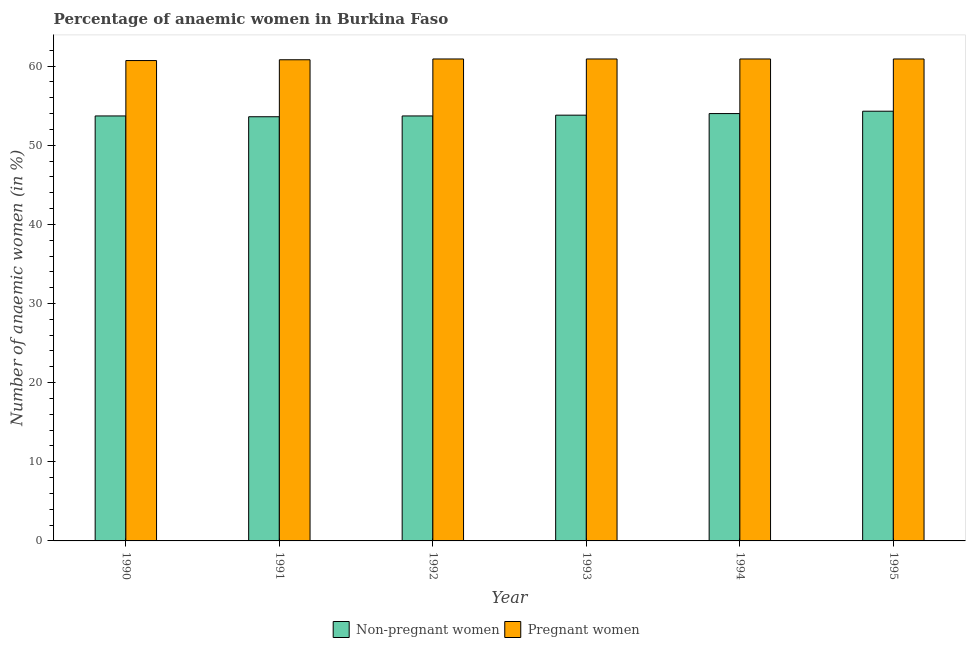How many groups of bars are there?
Ensure brevity in your answer.  6. How many bars are there on the 4th tick from the left?
Offer a terse response. 2. How many bars are there on the 2nd tick from the right?
Offer a terse response. 2. What is the label of the 1st group of bars from the left?
Provide a succinct answer. 1990. In how many cases, is the number of bars for a given year not equal to the number of legend labels?
Offer a terse response. 0. What is the percentage of non-pregnant anaemic women in 1990?
Provide a succinct answer. 53.7. Across all years, what is the maximum percentage of pregnant anaemic women?
Your response must be concise. 60.9. Across all years, what is the minimum percentage of non-pregnant anaemic women?
Offer a terse response. 53.6. In which year was the percentage of pregnant anaemic women minimum?
Provide a succinct answer. 1990. What is the total percentage of non-pregnant anaemic women in the graph?
Provide a succinct answer. 323.1. What is the difference between the percentage of pregnant anaemic women in 1992 and that in 1993?
Offer a very short reply. 0. What is the difference between the percentage of non-pregnant anaemic women in 1992 and the percentage of pregnant anaemic women in 1993?
Your answer should be compact. -0.1. What is the average percentage of non-pregnant anaemic women per year?
Provide a short and direct response. 53.85. In the year 1990, what is the difference between the percentage of non-pregnant anaemic women and percentage of pregnant anaemic women?
Ensure brevity in your answer.  0. In how many years, is the percentage of non-pregnant anaemic women greater than 24 %?
Give a very brief answer. 6. What is the ratio of the percentage of non-pregnant anaemic women in 1990 to that in 1991?
Provide a short and direct response. 1. What is the difference between the highest and the second highest percentage of pregnant anaemic women?
Your answer should be compact. 0. What is the difference between the highest and the lowest percentage of pregnant anaemic women?
Your answer should be compact. 0.2. In how many years, is the percentage of non-pregnant anaemic women greater than the average percentage of non-pregnant anaemic women taken over all years?
Make the answer very short. 2. Is the sum of the percentage of non-pregnant anaemic women in 1992 and 1994 greater than the maximum percentage of pregnant anaemic women across all years?
Ensure brevity in your answer.  Yes. What does the 1st bar from the left in 1994 represents?
Give a very brief answer. Non-pregnant women. What does the 1st bar from the right in 1990 represents?
Your response must be concise. Pregnant women. What is the difference between two consecutive major ticks on the Y-axis?
Make the answer very short. 10. Are the values on the major ticks of Y-axis written in scientific E-notation?
Give a very brief answer. No. Does the graph contain grids?
Make the answer very short. No. Where does the legend appear in the graph?
Ensure brevity in your answer.  Bottom center. How are the legend labels stacked?
Provide a short and direct response. Horizontal. What is the title of the graph?
Keep it short and to the point. Percentage of anaemic women in Burkina Faso. What is the label or title of the X-axis?
Your response must be concise. Year. What is the label or title of the Y-axis?
Offer a very short reply. Number of anaemic women (in %). What is the Number of anaemic women (in %) in Non-pregnant women in 1990?
Your answer should be very brief. 53.7. What is the Number of anaemic women (in %) of Pregnant women in 1990?
Ensure brevity in your answer.  60.7. What is the Number of anaemic women (in %) in Non-pregnant women in 1991?
Your answer should be compact. 53.6. What is the Number of anaemic women (in %) in Pregnant women in 1991?
Your answer should be very brief. 60.8. What is the Number of anaemic women (in %) in Non-pregnant women in 1992?
Provide a short and direct response. 53.7. What is the Number of anaemic women (in %) in Pregnant women in 1992?
Keep it short and to the point. 60.9. What is the Number of anaemic women (in %) of Non-pregnant women in 1993?
Your response must be concise. 53.8. What is the Number of anaemic women (in %) in Pregnant women in 1993?
Your answer should be very brief. 60.9. What is the Number of anaemic women (in %) of Pregnant women in 1994?
Your answer should be very brief. 60.9. What is the Number of anaemic women (in %) of Non-pregnant women in 1995?
Your response must be concise. 54.3. What is the Number of anaemic women (in %) in Pregnant women in 1995?
Provide a short and direct response. 60.9. Across all years, what is the maximum Number of anaemic women (in %) of Non-pregnant women?
Your answer should be compact. 54.3. Across all years, what is the maximum Number of anaemic women (in %) in Pregnant women?
Your answer should be compact. 60.9. Across all years, what is the minimum Number of anaemic women (in %) of Non-pregnant women?
Provide a succinct answer. 53.6. Across all years, what is the minimum Number of anaemic women (in %) in Pregnant women?
Your answer should be very brief. 60.7. What is the total Number of anaemic women (in %) of Non-pregnant women in the graph?
Provide a short and direct response. 323.1. What is the total Number of anaemic women (in %) in Pregnant women in the graph?
Your answer should be compact. 365.1. What is the difference between the Number of anaemic women (in %) of Pregnant women in 1990 and that in 1991?
Provide a succinct answer. -0.1. What is the difference between the Number of anaemic women (in %) of Pregnant women in 1990 and that in 1992?
Offer a very short reply. -0.2. What is the difference between the Number of anaemic women (in %) of Non-pregnant women in 1990 and that in 1993?
Ensure brevity in your answer.  -0.1. What is the difference between the Number of anaemic women (in %) in Pregnant women in 1990 and that in 1993?
Keep it short and to the point. -0.2. What is the difference between the Number of anaemic women (in %) in Pregnant women in 1991 and that in 1992?
Provide a succinct answer. -0.1. What is the difference between the Number of anaemic women (in %) of Non-pregnant women in 1991 and that in 1993?
Your response must be concise. -0.2. What is the difference between the Number of anaemic women (in %) in Pregnant women in 1991 and that in 1993?
Make the answer very short. -0.1. What is the difference between the Number of anaemic women (in %) in Non-pregnant women in 1991 and that in 1995?
Offer a terse response. -0.7. What is the difference between the Number of anaemic women (in %) in Non-pregnant women in 1992 and that in 1994?
Give a very brief answer. -0.3. What is the difference between the Number of anaemic women (in %) in Pregnant women in 1992 and that in 1994?
Your answer should be compact. 0. What is the difference between the Number of anaemic women (in %) in Non-pregnant women in 1993 and that in 1994?
Provide a succinct answer. -0.2. What is the difference between the Number of anaemic women (in %) in Pregnant women in 1993 and that in 1994?
Offer a terse response. 0. What is the difference between the Number of anaemic women (in %) of Non-pregnant women in 1994 and that in 1995?
Offer a very short reply. -0.3. What is the difference between the Number of anaemic women (in %) of Pregnant women in 1994 and that in 1995?
Ensure brevity in your answer.  0. What is the difference between the Number of anaemic women (in %) in Non-pregnant women in 1990 and the Number of anaemic women (in %) in Pregnant women in 1991?
Give a very brief answer. -7.1. What is the difference between the Number of anaemic women (in %) in Non-pregnant women in 1990 and the Number of anaemic women (in %) in Pregnant women in 1994?
Give a very brief answer. -7.2. What is the difference between the Number of anaemic women (in %) of Non-pregnant women in 1991 and the Number of anaemic women (in %) of Pregnant women in 1993?
Keep it short and to the point. -7.3. What is the difference between the Number of anaemic women (in %) of Non-pregnant women in 1991 and the Number of anaemic women (in %) of Pregnant women in 1995?
Offer a very short reply. -7.3. What is the difference between the Number of anaemic women (in %) of Non-pregnant women in 1992 and the Number of anaemic women (in %) of Pregnant women in 1993?
Make the answer very short. -7.2. What is the difference between the Number of anaemic women (in %) of Non-pregnant women in 1992 and the Number of anaemic women (in %) of Pregnant women in 1995?
Your answer should be very brief. -7.2. What is the difference between the Number of anaemic women (in %) in Non-pregnant women in 1993 and the Number of anaemic women (in %) in Pregnant women in 1994?
Keep it short and to the point. -7.1. What is the average Number of anaemic women (in %) of Non-pregnant women per year?
Offer a very short reply. 53.85. What is the average Number of anaemic women (in %) of Pregnant women per year?
Provide a succinct answer. 60.85. In the year 1990, what is the difference between the Number of anaemic women (in %) of Non-pregnant women and Number of anaemic women (in %) of Pregnant women?
Offer a very short reply. -7. In the year 1992, what is the difference between the Number of anaemic women (in %) in Non-pregnant women and Number of anaemic women (in %) in Pregnant women?
Offer a very short reply. -7.2. In the year 1994, what is the difference between the Number of anaemic women (in %) in Non-pregnant women and Number of anaemic women (in %) in Pregnant women?
Your response must be concise. -6.9. In the year 1995, what is the difference between the Number of anaemic women (in %) of Non-pregnant women and Number of anaemic women (in %) of Pregnant women?
Your response must be concise. -6.6. What is the ratio of the Number of anaemic women (in %) in Non-pregnant women in 1990 to that in 1991?
Offer a very short reply. 1. What is the ratio of the Number of anaemic women (in %) in Pregnant women in 1990 to that in 1991?
Your answer should be very brief. 1. What is the ratio of the Number of anaemic women (in %) in Non-pregnant women in 1990 to that in 1992?
Your answer should be compact. 1. What is the ratio of the Number of anaemic women (in %) in Pregnant women in 1990 to that in 1992?
Make the answer very short. 1. What is the ratio of the Number of anaemic women (in %) of Non-pregnant women in 1990 to that in 1994?
Provide a short and direct response. 0.99. What is the ratio of the Number of anaemic women (in %) of Pregnant women in 1990 to that in 1994?
Ensure brevity in your answer.  1. What is the ratio of the Number of anaemic women (in %) of Non-pregnant women in 1990 to that in 1995?
Your answer should be very brief. 0.99. What is the ratio of the Number of anaemic women (in %) in Pregnant women in 1991 to that in 1992?
Offer a terse response. 1. What is the ratio of the Number of anaemic women (in %) of Non-pregnant women in 1991 to that in 1993?
Give a very brief answer. 1. What is the ratio of the Number of anaemic women (in %) of Pregnant women in 1991 to that in 1993?
Make the answer very short. 1. What is the ratio of the Number of anaemic women (in %) of Non-pregnant women in 1991 to that in 1994?
Offer a very short reply. 0.99. What is the ratio of the Number of anaemic women (in %) in Non-pregnant women in 1991 to that in 1995?
Your response must be concise. 0.99. What is the ratio of the Number of anaemic women (in %) in Pregnant women in 1991 to that in 1995?
Ensure brevity in your answer.  1. What is the ratio of the Number of anaemic women (in %) in Pregnant women in 1992 to that in 1993?
Make the answer very short. 1. What is the ratio of the Number of anaemic women (in %) in Non-pregnant women in 1992 to that in 1994?
Provide a succinct answer. 0.99. What is the ratio of the Number of anaemic women (in %) of Pregnant women in 1992 to that in 1995?
Offer a terse response. 1. What is the ratio of the Number of anaemic women (in %) of Non-pregnant women in 1993 to that in 1994?
Offer a very short reply. 1. What is the ratio of the Number of anaemic women (in %) of Pregnant women in 1994 to that in 1995?
Provide a short and direct response. 1. What is the difference between the highest and the second highest Number of anaemic women (in %) in Non-pregnant women?
Keep it short and to the point. 0.3. What is the difference between the highest and the second highest Number of anaemic women (in %) in Pregnant women?
Offer a terse response. 0. 